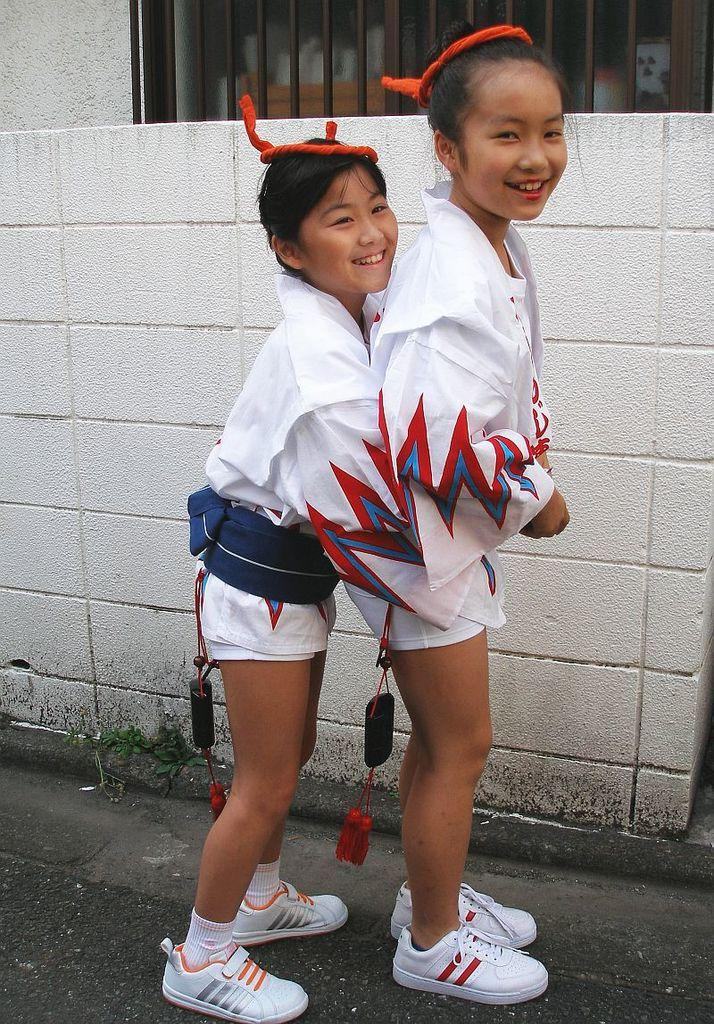How many people are in the image? There are two girls in the image. Where are the girls located in the image? The girls are standing in the center of the image. What can be seen in the background of the image? There is a wall and a window in the background of the image. What is visible at the bottom of the image? The ground is visible at the bottom of the image. What type of waves can be seen crashing against the shore in the image? There are no waves or shore visible in the image; it features two girls standing in the center with a wall and window in the background. 